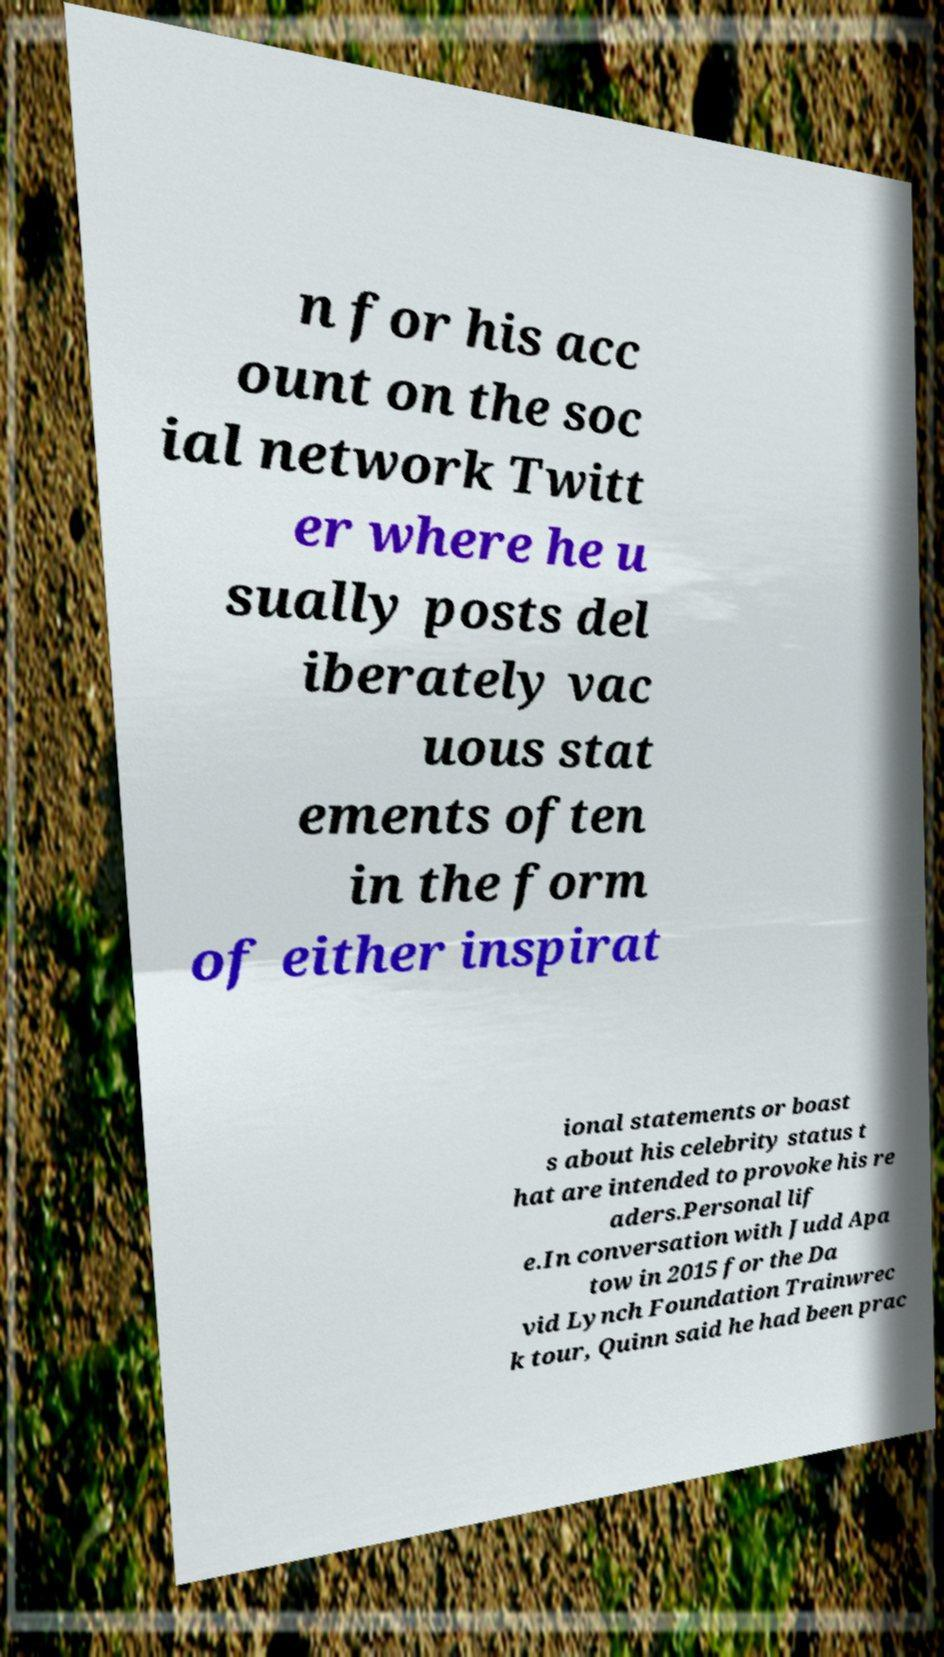Please identify and transcribe the text found in this image. n for his acc ount on the soc ial network Twitt er where he u sually posts del iberately vac uous stat ements often in the form of either inspirat ional statements or boast s about his celebrity status t hat are intended to provoke his re aders.Personal lif e.In conversation with Judd Apa tow in 2015 for the Da vid Lynch Foundation Trainwrec k tour, Quinn said he had been prac 